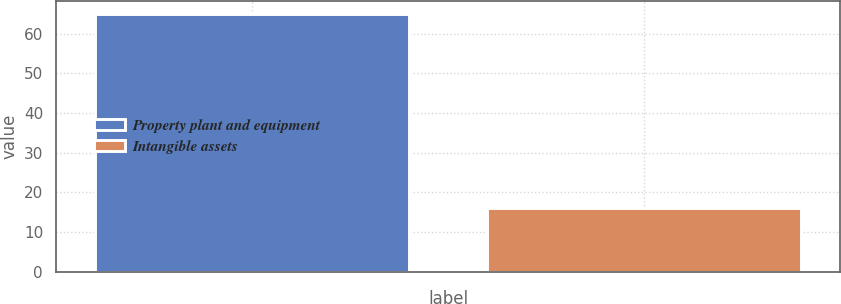<chart> <loc_0><loc_0><loc_500><loc_500><bar_chart><fcel>Property plant and equipment<fcel>Intangible assets<nl><fcel>65<fcel>16<nl></chart> 